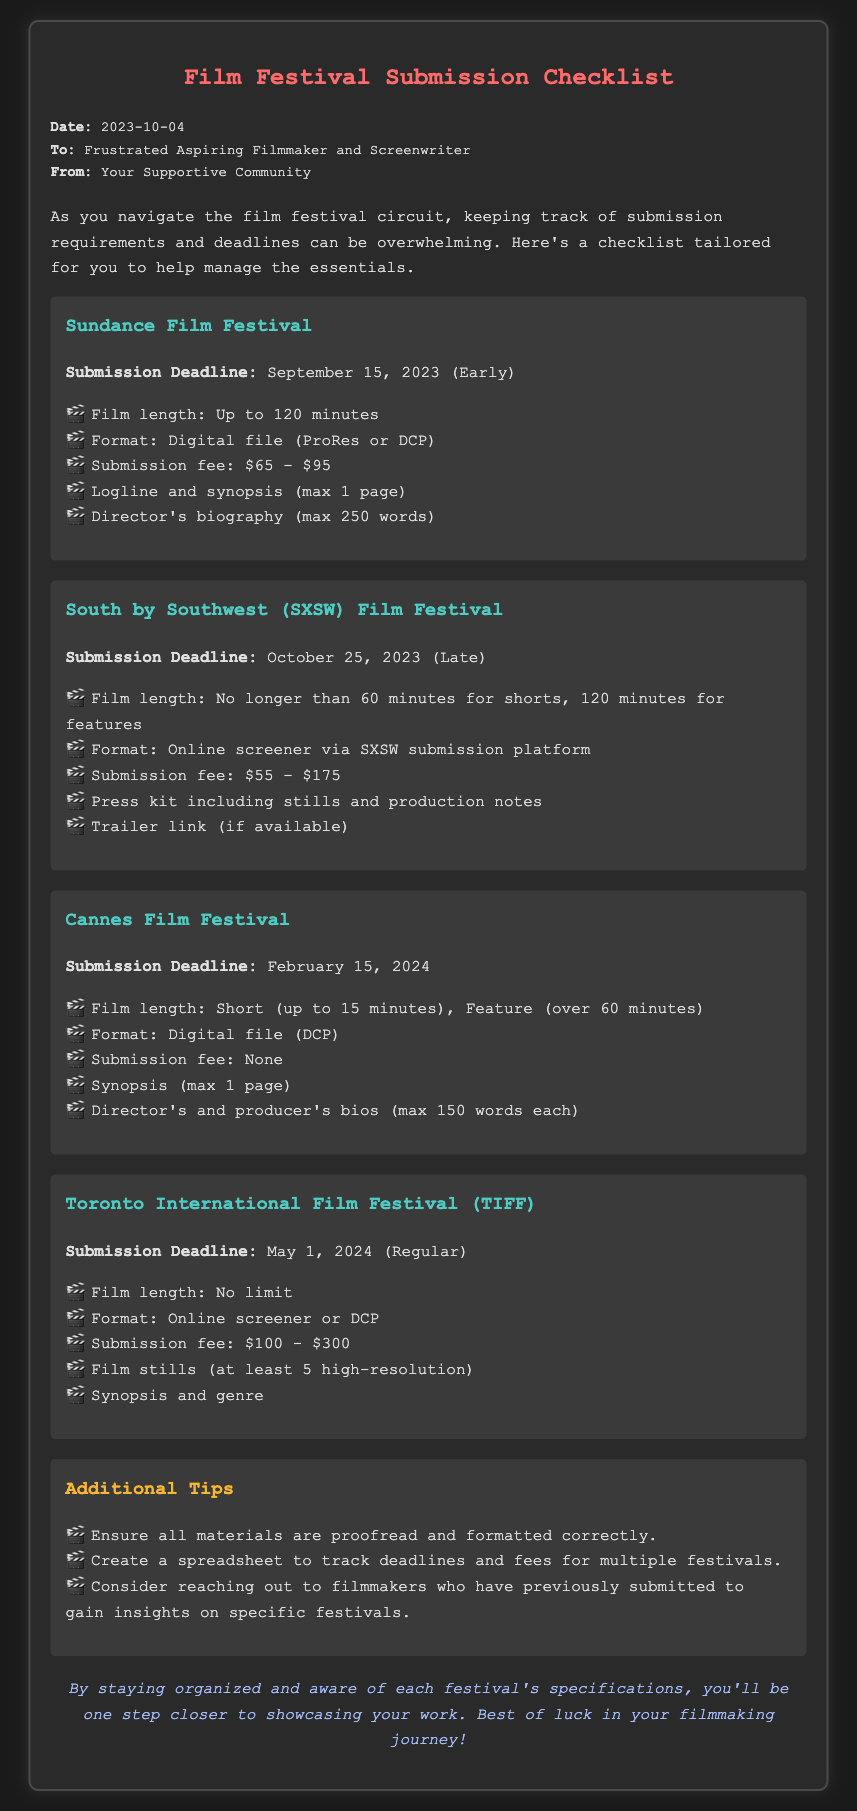What is the submission deadline for Sundance Film Festival? The submission deadline for Sundance Film Festival is specified as September 15, 2023 (Early).
Answer: September 15, 2023 What is the submission fee range for South by Southwest (SXSW) Film Festival? The document lists the submission fee for South by Southwest (SXSW) Film Festival as $55 - $175.
Answer: $55 - $175 What is the film length requirement for features at Cannes Film Festival? The document states that the film length for features at Cannes Film Festival is over 60 minutes.
Answer: over 60 minutes Which festival has a submission deadline of February 15, 2024? The Cannes Film Festival has a submission deadline that is noted as February 15, 2024.
Answer: Cannes Film Festival What materials are required for the Toronto International Film Festival submission? The document mentions film stills (at least 5 high-resolution) and synopsis and genre as required materials for TIFF.
Answer: film stills and synopsis and genre What is the earliest submission deadline mentioned in the document? The earliest submission deadline in the document is for Sundance Film Festival, which is September 15, 2023.
Answer: September 15, 2023 What type of file format is required for submissions to the Cannes Film Festival? The required format for submissions to the Cannes Film Festival is specified as Digital file (DCP).
Answer: Digital file (DCP) What additional tip is suggested for managing multiple festival submissions? The document suggests creating a spreadsheet to track deadlines and fees for multiple festivals as an additional tip.
Answer: create a spreadsheet What is the maximum length for short films at South by Southwest (SXSW) Film Festival? The document states that the maximum length for short films at SXSW is no longer than 60 minutes.
Answer: 60 minutes 